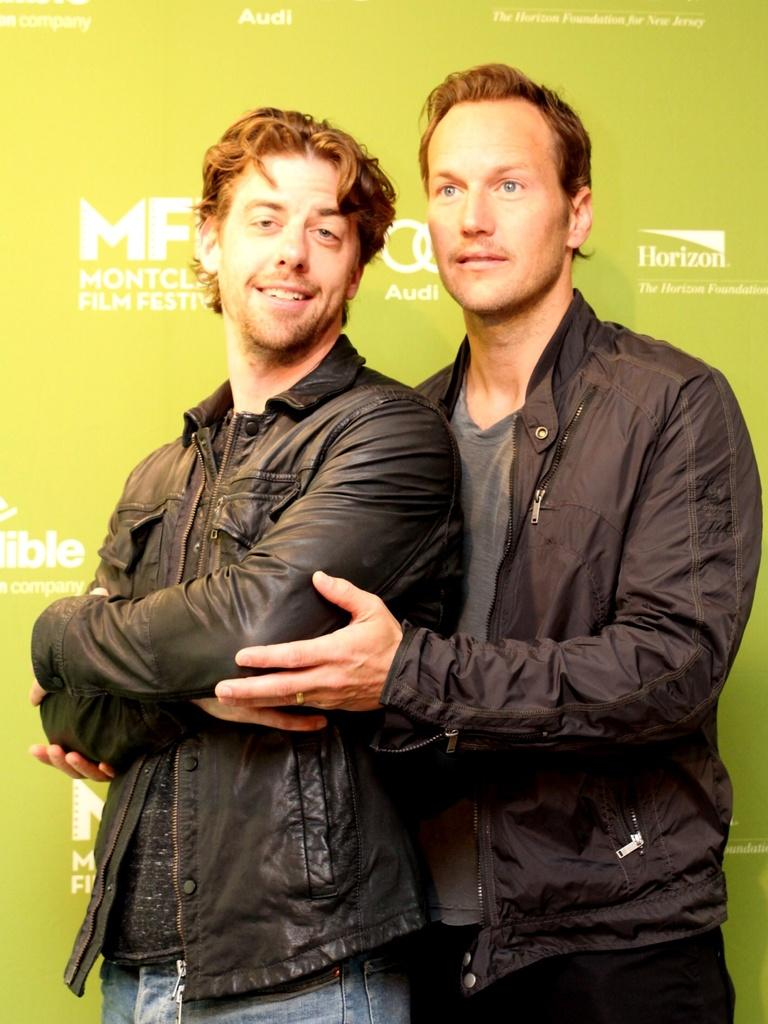How many people are in the image? There are two people in the image. What is the person on the left wearing? The person on the left is wearing a black coat. What is the person in the black coat doing? The person in the black coat is holding another person's hand. What can be seen in the background of the image? There is a wall in the background of the image, and there is text on the wall. Is there a boat visible in the image? No, there is no boat present in the image. What type of ice can be seen melting on the wall in the background? There is no ice visible in the image, and the wall in the background does not have any ice on it. 